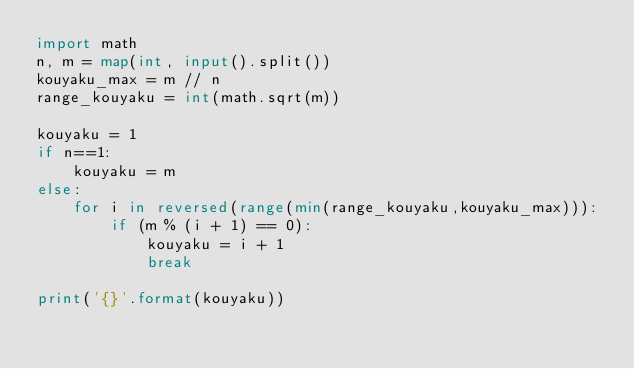Convert code to text. <code><loc_0><loc_0><loc_500><loc_500><_Python_>import math
n, m = map(int, input().split())
kouyaku_max = m // n
range_kouyaku = int(math.sqrt(m))

kouyaku = 1
if n==1:
    kouyaku = m
else:
    for i in reversed(range(min(range_kouyaku,kouyaku_max))):
        if (m % (i + 1) == 0):
            kouyaku = i + 1
            break

print('{}'.format(kouyaku))</code> 